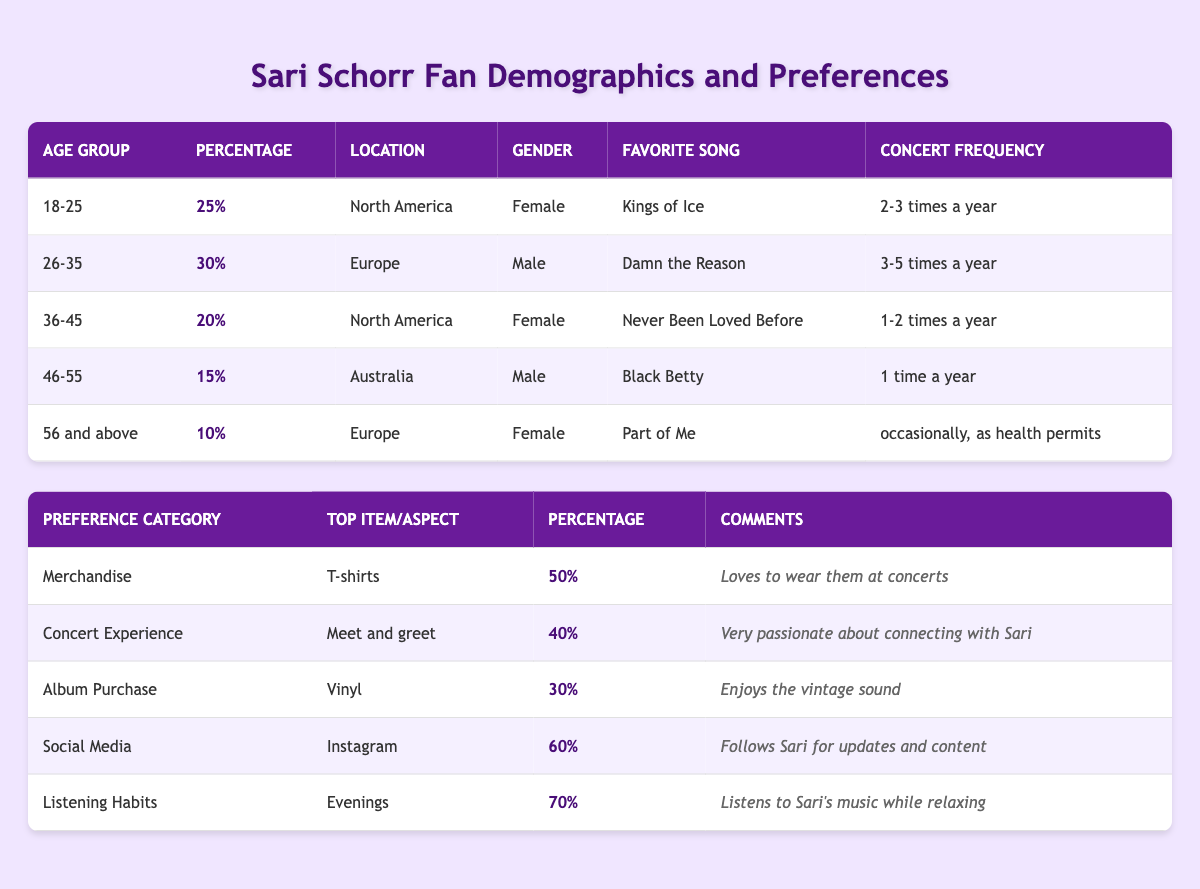What percentage of fans are aged 26-35? According to the table, the percentage of fans in the age group 26-35 is listed as 30%.
Answer: 30% Which age group has the highest percentage of fans? The age group 26-35 has the highest percentage at 30%, compared to other age groups listed.
Answer: 26-35 What is the favorite song of the age group 56 and above? The favorite song for the age group 56 and above, according to the table, is "Part of Me."
Answer: Part of Me What percentage of fans are located in North America? There are fans in North America aged 18-25 (25%) and 36-45 (20%). Adding these gives 25% + 20% = 45%.
Answer: 45% How often do fans aged 46-55 attend concerts? Fans in the age group 46-55 attend concerts 1 time a year, based on the data in the table.
Answer: 1 time a year Which merchandise item has the highest preference among fans? The largest percentage reported for a merchandise item is 50% for T-shirts.
Answer: T-shirts What is the second most popular social media platform among fans? Since Instagram is the only platform mentioned with a specific value (60%), we cannot determine a second most popular platform from the provided data.
Answer: Not applicable How many fans prefer to listen to Sari's music in the mornings? The table does not specify a percentage for listening habits in the mornings, only stating that 70% listen in the evenings.
Answer: Not applicable What is the total percentage of fans who prefer meet-and-greets and T-shirts? The percentage for meet-and-greet is 40%, and for T-shirts is 50%. Adding these gives 40% + 50% = 90%.
Answer: 90% Is it true that the majority of fans prefer listening to music in the evenings? Yes, 70% of fans prefer the evening for listening, which indicates the majority since it’s over 50%.
Answer: True What is the favorite song for the largest demographic group based on location? The largest demographic group based on location is North America with 45% of fans (18-25 and 36-45 combined), and their favorite songs are "Kings of Ice" and "Never Been Loved Before."
Answer: Kings of Ice and Never Been Loved Before 